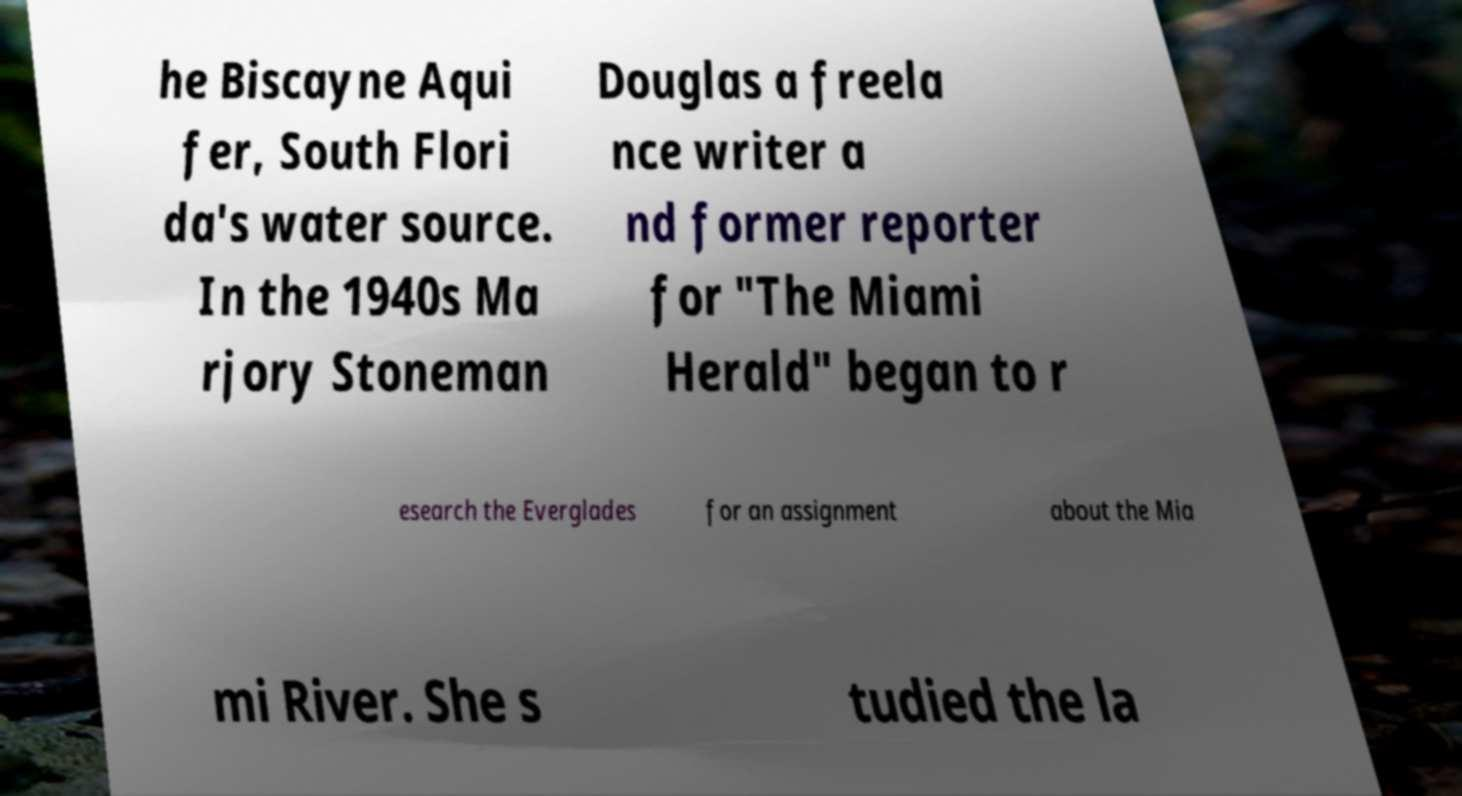Please read and relay the text visible in this image. What does it say? he Biscayne Aqui fer, South Flori da's water source. In the 1940s Ma rjory Stoneman Douglas a freela nce writer a nd former reporter for "The Miami Herald" began to r esearch the Everglades for an assignment about the Mia mi River. She s tudied the la 